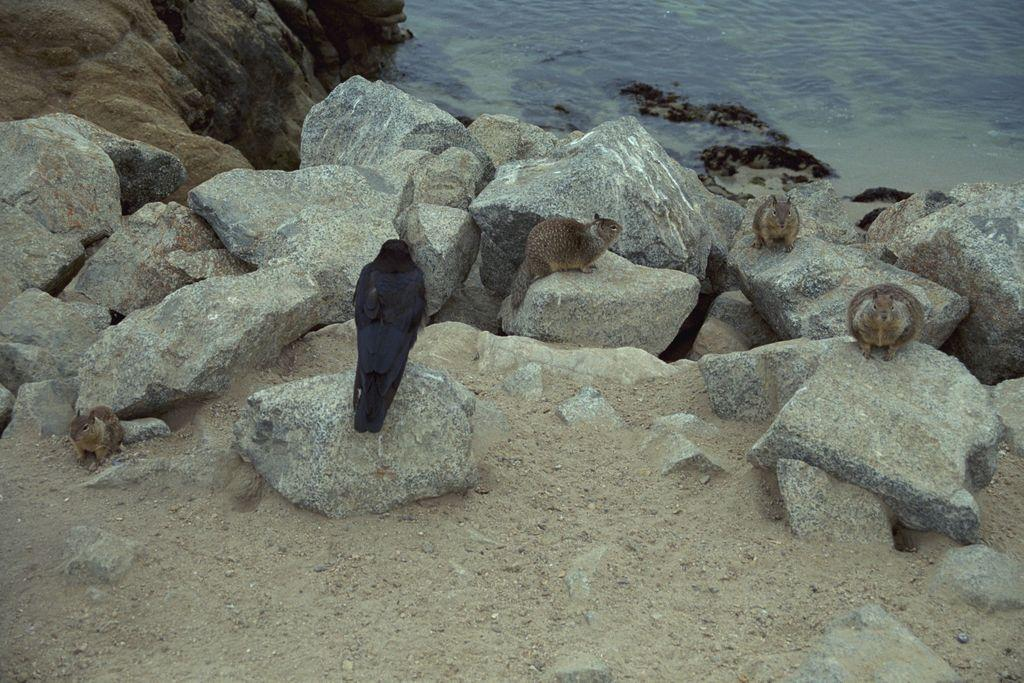What type of animal can be seen in the image besides the bird? There is another animal in the image. What objects are visible in the image? The stones are visible in the image. What can be seen in the background of the image? There is water in the background of the image. What is at the bottom of the image? There is sand at the bottom of the image. What type of cart can be seen in the image? There is no cart present in the image. What form does the bird take in the image? The bird is depicted in its natural form in the image. 